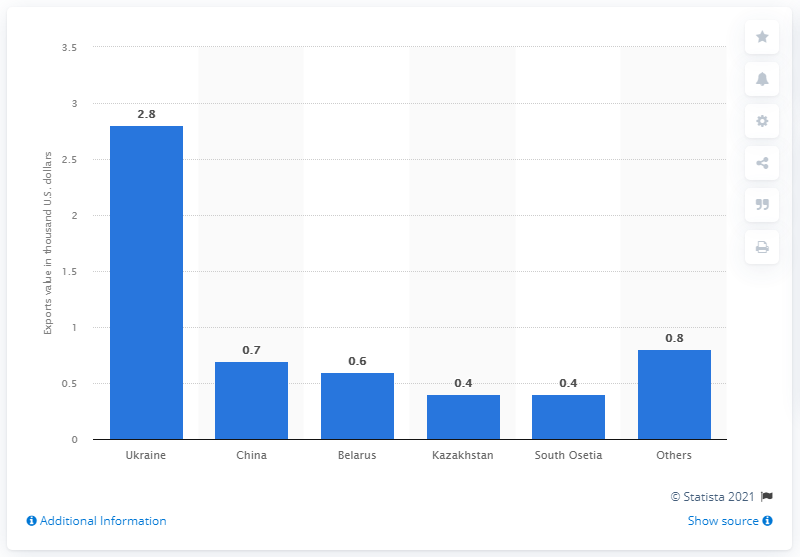List a handful of essential elements in this visual. In 2020, Belarus was the third largest importer of Russian wine. 